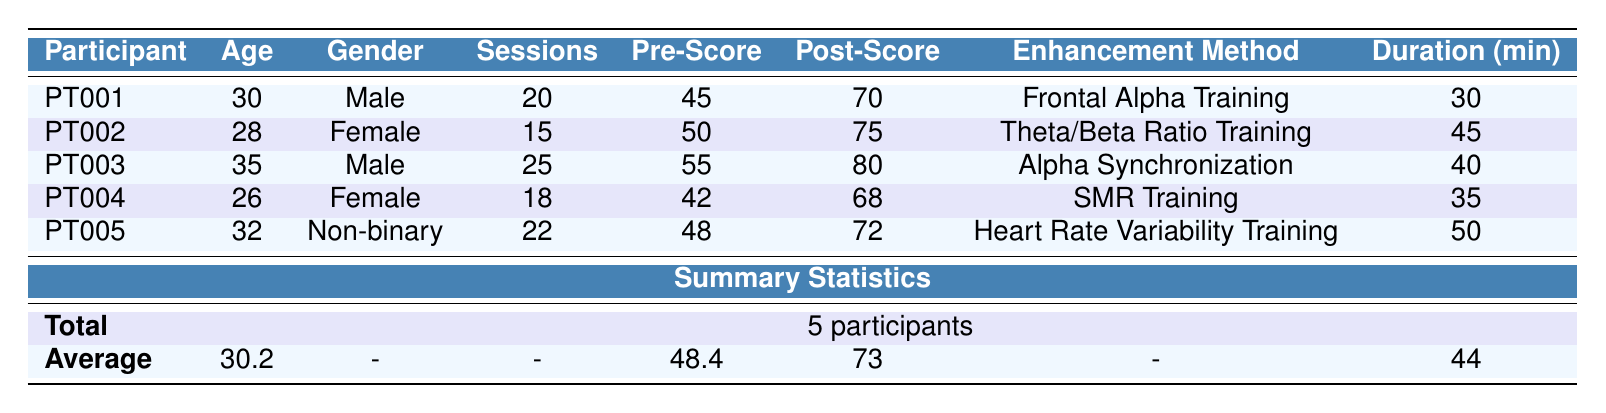What was the average age of the participants? The total number of participants is 5, and their ages are 30, 28, 35, 26, and 32. To find the average, sum the ages (30 + 28 + 35 + 26 + 32 = 151) and divide by the number of participants (151 / 5 = 30.2).
Answer: 30.2 How many training sessions did PT002 undergo? The table directly shows that PT002 had 15 training sessions listed under the "Sessions" column.
Answer: 15 What enhancement method was used by PT003? Referring to the table, the enhancement method for PT003 is recorded as "Alpha Synchronization" in the respective column.
Answer: Alpha Synchronization Did PT005 achieve a higher post-training innovation score than PT001? PT005’s post-training score is 72, while PT001’s is 70. Since 72 is greater than 70, this statement is true.
Answer: Yes What is the difference between the average pre-training and post-training innovation scores? The average pre-training score is 48.4 and the average post-training score is 73. To find the difference, subtract 48.4 from 73 (73 - 48.4 = 24.6).
Answer: 24.6 Is there any participant whose post-training score did not increase? The table shows that all participants’ post-training scores are higher than their pre-training scores (PT001: 70, PT002: 75, PT003: 80, PT004: 68, PT005: 72), indicating no participant experienced a decrease.
Answer: No Which cognitive enhancement method had the longest average session duration? The session durations are 30, 45, 40, 35, and 50 minutes. The longest duration is 50 minutes for PT005.
Answer: Heart Rate Variability Training How much did PT004’s innovation score increase after training? The pre-training score for PT004 was 42 and the post-training score was 68. The increase is computed as (68 - 42 = 26).
Answer: 26 What percentage of participants had a post-training score above 75? There are 5 participants total, and PT002 and PT003 had post-training scores of 75 and 80, respectively. So, 2 out of 5 had scores above 75, which is (2/5) * 100 = 40%.
Answer: 40% Which gender had the highest average post-training innovation score? The male participants (PT001 and PT003) had post-training scores of 70 and 80, averaging (70 + 80) / 2 = 75. The female participants (PT002 and PT004) had scores of 75 and 68, averaging (75 + 68) / 2 = 71.5. Therefore, males had the higher average score.
Answer: Male 